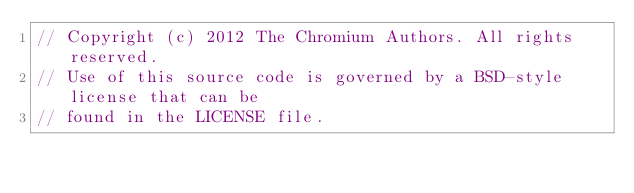Convert code to text. <code><loc_0><loc_0><loc_500><loc_500><_C++_>// Copyright (c) 2012 The Chromium Authors. All rights reserved.
// Use of this source code is governed by a BSD-style license that can be
// found in the LICENSE file.
</code> 